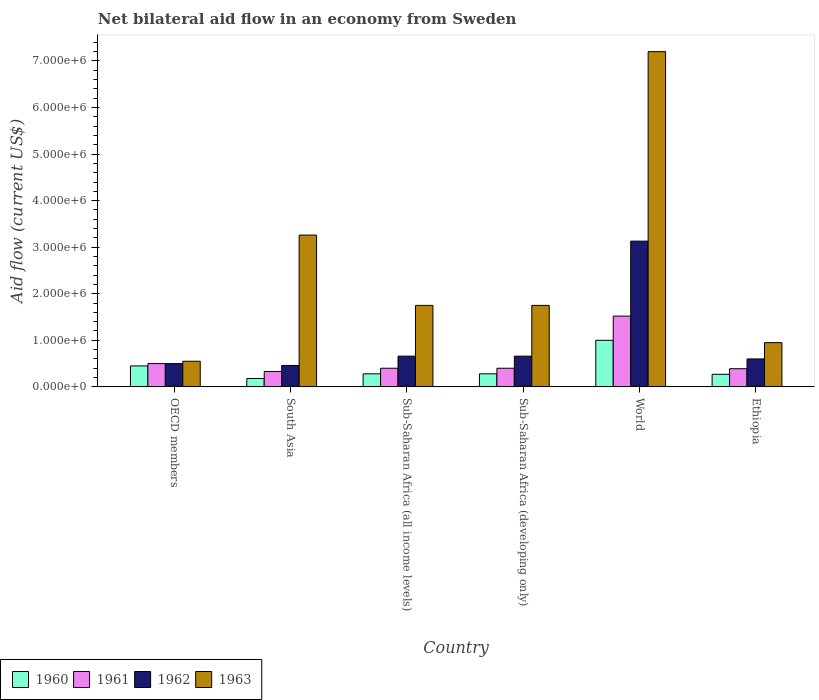How many different coloured bars are there?
Your answer should be very brief. 4. How many groups of bars are there?
Offer a terse response. 6. Are the number of bars per tick equal to the number of legend labels?
Offer a terse response. Yes. Are the number of bars on each tick of the X-axis equal?
Your response must be concise. Yes. How many bars are there on the 6th tick from the left?
Keep it short and to the point. 4. What is the label of the 2nd group of bars from the left?
Offer a very short reply. South Asia. What is the net bilateral aid flow in 1963 in OECD members?
Give a very brief answer. 5.50e+05. Across all countries, what is the maximum net bilateral aid flow in 1962?
Offer a terse response. 3.13e+06. Across all countries, what is the minimum net bilateral aid flow in 1960?
Make the answer very short. 1.80e+05. In which country was the net bilateral aid flow in 1962 maximum?
Provide a succinct answer. World. What is the total net bilateral aid flow in 1963 in the graph?
Ensure brevity in your answer.  1.55e+07. What is the difference between the net bilateral aid flow in 1963 in Ethiopia and that in Sub-Saharan Africa (developing only)?
Provide a short and direct response. -8.00e+05. What is the difference between the net bilateral aid flow in 1961 in World and the net bilateral aid flow in 1962 in Sub-Saharan Africa (all income levels)?
Make the answer very short. 8.60e+05. What is the average net bilateral aid flow in 1962 per country?
Your response must be concise. 1.00e+06. What is the difference between the net bilateral aid flow of/in 1963 and net bilateral aid flow of/in 1960 in Sub-Saharan Africa (developing only)?
Keep it short and to the point. 1.47e+06. What is the ratio of the net bilateral aid flow in 1961 in Ethiopia to that in Sub-Saharan Africa (developing only)?
Offer a terse response. 0.97. Is the net bilateral aid flow in 1960 in Sub-Saharan Africa (developing only) less than that in World?
Make the answer very short. Yes. Is the difference between the net bilateral aid flow in 1963 in OECD members and South Asia greater than the difference between the net bilateral aid flow in 1960 in OECD members and South Asia?
Your answer should be very brief. No. What is the difference between the highest and the second highest net bilateral aid flow in 1962?
Provide a short and direct response. 2.47e+06. What is the difference between the highest and the lowest net bilateral aid flow in 1961?
Offer a terse response. 1.19e+06. Is the sum of the net bilateral aid flow in 1962 in Sub-Saharan Africa (all income levels) and World greater than the maximum net bilateral aid flow in 1961 across all countries?
Give a very brief answer. Yes. Is it the case that in every country, the sum of the net bilateral aid flow in 1963 and net bilateral aid flow in 1960 is greater than the sum of net bilateral aid flow in 1961 and net bilateral aid flow in 1962?
Provide a succinct answer. Yes. Is it the case that in every country, the sum of the net bilateral aid flow in 1960 and net bilateral aid flow in 1962 is greater than the net bilateral aid flow in 1961?
Provide a succinct answer. Yes. How many bars are there?
Give a very brief answer. 24. Are all the bars in the graph horizontal?
Offer a terse response. No. Are the values on the major ticks of Y-axis written in scientific E-notation?
Your response must be concise. Yes. Does the graph contain grids?
Provide a succinct answer. No. Where does the legend appear in the graph?
Keep it short and to the point. Bottom left. How are the legend labels stacked?
Make the answer very short. Horizontal. What is the title of the graph?
Provide a short and direct response. Net bilateral aid flow in an economy from Sweden. What is the Aid flow (current US$) of 1961 in OECD members?
Your answer should be compact. 5.00e+05. What is the Aid flow (current US$) in 1962 in OECD members?
Make the answer very short. 5.00e+05. What is the Aid flow (current US$) in 1960 in South Asia?
Provide a short and direct response. 1.80e+05. What is the Aid flow (current US$) in 1963 in South Asia?
Offer a terse response. 3.26e+06. What is the Aid flow (current US$) in 1961 in Sub-Saharan Africa (all income levels)?
Your answer should be very brief. 4.00e+05. What is the Aid flow (current US$) of 1962 in Sub-Saharan Africa (all income levels)?
Ensure brevity in your answer.  6.60e+05. What is the Aid flow (current US$) of 1963 in Sub-Saharan Africa (all income levels)?
Provide a succinct answer. 1.75e+06. What is the Aid flow (current US$) in 1960 in Sub-Saharan Africa (developing only)?
Keep it short and to the point. 2.80e+05. What is the Aid flow (current US$) in 1962 in Sub-Saharan Africa (developing only)?
Keep it short and to the point. 6.60e+05. What is the Aid flow (current US$) in 1963 in Sub-Saharan Africa (developing only)?
Make the answer very short. 1.75e+06. What is the Aid flow (current US$) of 1960 in World?
Ensure brevity in your answer.  1.00e+06. What is the Aid flow (current US$) of 1961 in World?
Provide a succinct answer. 1.52e+06. What is the Aid flow (current US$) in 1962 in World?
Provide a succinct answer. 3.13e+06. What is the Aid flow (current US$) in 1963 in World?
Offer a terse response. 7.20e+06. What is the Aid flow (current US$) in 1961 in Ethiopia?
Give a very brief answer. 3.90e+05. What is the Aid flow (current US$) in 1962 in Ethiopia?
Give a very brief answer. 6.00e+05. What is the Aid flow (current US$) of 1963 in Ethiopia?
Make the answer very short. 9.50e+05. Across all countries, what is the maximum Aid flow (current US$) in 1961?
Give a very brief answer. 1.52e+06. Across all countries, what is the maximum Aid flow (current US$) of 1962?
Provide a succinct answer. 3.13e+06. Across all countries, what is the maximum Aid flow (current US$) of 1963?
Offer a very short reply. 7.20e+06. Across all countries, what is the minimum Aid flow (current US$) in 1961?
Your answer should be compact. 3.30e+05. Across all countries, what is the minimum Aid flow (current US$) in 1963?
Offer a very short reply. 5.50e+05. What is the total Aid flow (current US$) in 1960 in the graph?
Your answer should be very brief. 2.46e+06. What is the total Aid flow (current US$) in 1961 in the graph?
Provide a succinct answer. 3.54e+06. What is the total Aid flow (current US$) of 1962 in the graph?
Ensure brevity in your answer.  6.01e+06. What is the total Aid flow (current US$) in 1963 in the graph?
Your response must be concise. 1.55e+07. What is the difference between the Aid flow (current US$) of 1960 in OECD members and that in South Asia?
Offer a terse response. 2.70e+05. What is the difference between the Aid flow (current US$) of 1961 in OECD members and that in South Asia?
Provide a short and direct response. 1.70e+05. What is the difference between the Aid flow (current US$) of 1963 in OECD members and that in South Asia?
Make the answer very short. -2.71e+06. What is the difference between the Aid flow (current US$) of 1960 in OECD members and that in Sub-Saharan Africa (all income levels)?
Provide a succinct answer. 1.70e+05. What is the difference between the Aid flow (current US$) in 1963 in OECD members and that in Sub-Saharan Africa (all income levels)?
Make the answer very short. -1.20e+06. What is the difference between the Aid flow (current US$) of 1963 in OECD members and that in Sub-Saharan Africa (developing only)?
Keep it short and to the point. -1.20e+06. What is the difference between the Aid flow (current US$) of 1960 in OECD members and that in World?
Provide a short and direct response. -5.50e+05. What is the difference between the Aid flow (current US$) of 1961 in OECD members and that in World?
Your answer should be very brief. -1.02e+06. What is the difference between the Aid flow (current US$) of 1962 in OECD members and that in World?
Offer a very short reply. -2.63e+06. What is the difference between the Aid flow (current US$) of 1963 in OECD members and that in World?
Offer a very short reply. -6.65e+06. What is the difference between the Aid flow (current US$) in 1960 in OECD members and that in Ethiopia?
Your answer should be very brief. 1.80e+05. What is the difference between the Aid flow (current US$) of 1963 in OECD members and that in Ethiopia?
Offer a very short reply. -4.00e+05. What is the difference between the Aid flow (current US$) in 1963 in South Asia and that in Sub-Saharan Africa (all income levels)?
Offer a terse response. 1.51e+06. What is the difference between the Aid flow (current US$) of 1960 in South Asia and that in Sub-Saharan Africa (developing only)?
Make the answer very short. -1.00e+05. What is the difference between the Aid flow (current US$) in 1961 in South Asia and that in Sub-Saharan Africa (developing only)?
Offer a terse response. -7.00e+04. What is the difference between the Aid flow (current US$) in 1962 in South Asia and that in Sub-Saharan Africa (developing only)?
Make the answer very short. -2.00e+05. What is the difference between the Aid flow (current US$) of 1963 in South Asia and that in Sub-Saharan Africa (developing only)?
Your answer should be compact. 1.51e+06. What is the difference between the Aid flow (current US$) of 1960 in South Asia and that in World?
Provide a short and direct response. -8.20e+05. What is the difference between the Aid flow (current US$) of 1961 in South Asia and that in World?
Make the answer very short. -1.19e+06. What is the difference between the Aid flow (current US$) of 1962 in South Asia and that in World?
Provide a succinct answer. -2.67e+06. What is the difference between the Aid flow (current US$) in 1963 in South Asia and that in World?
Keep it short and to the point. -3.94e+06. What is the difference between the Aid flow (current US$) of 1960 in South Asia and that in Ethiopia?
Your answer should be very brief. -9.00e+04. What is the difference between the Aid flow (current US$) of 1963 in South Asia and that in Ethiopia?
Provide a succinct answer. 2.31e+06. What is the difference between the Aid flow (current US$) in 1960 in Sub-Saharan Africa (all income levels) and that in Sub-Saharan Africa (developing only)?
Offer a terse response. 0. What is the difference between the Aid flow (current US$) of 1962 in Sub-Saharan Africa (all income levels) and that in Sub-Saharan Africa (developing only)?
Offer a terse response. 0. What is the difference between the Aid flow (current US$) in 1963 in Sub-Saharan Africa (all income levels) and that in Sub-Saharan Africa (developing only)?
Give a very brief answer. 0. What is the difference between the Aid flow (current US$) in 1960 in Sub-Saharan Africa (all income levels) and that in World?
Keep it short and to the point. -7.20e+05. What is the difference between the Aid flow (current US$) in 1961 in Sub-Saharan Africa (all income levels) and that in World?
Offer a terse response. -1.12e+06. What is the difference between the Aid flow (current US$) in 1962 in Sub-Saharan Africa (all income levels) and that in World?
Your answer should be very brief. -2.47e+06. What is the difference between the Aid flow (current US$) in 1963 in Sub-Saharan Africa (all income levels) and that in World?
Provide a succinct answer. -5.45e+06. What is the difference between the Aid flow (current US$) of 1960 in Sub-Saharan Africa (all income levels) and that in Ethiopia?
Offer a terse response. 10000. What is the difference between the Aid flow (current US$) in 1963 in Sub-Saharan Africa (all income levels) and that in Ethiopia?
Your answer should be very brief. 8.00e+05. What is the difference between the Aid flow (current US$) of 1960 in Sub-Saharan Africa (developing only) and that in World?
Give a very brief answer. -7.20e+05. What is the difference between the Aid flow (current US$) in 1961 in Sub-Saharan Africa (developing only) and that in World?
Give a very brief answer. -1.12e+06. What is the difference between the Aid flow (current US$) in 1962 in Sub-Saharan Africa (developing only) and that in World?
Your answer should be very brief. -2.47e+06. What is the difference between the Aid flow (current US$) in 1963 in Sub-Saharan Africa (developing only) and that in World?
Give a very brief answer. -5.45e+06. What is the difference between the Aid flow (current US$) in 1963 in Sub-Saharan Africa (developing only) and that in Ethiopia?
Make the answer very short. 8.00e+05. What is the difference between the Aid flow (current US$) in 1960 in World and that in Ethiopia?
Your answer should be very brief. 7.30e+05. What is the difference between the Aid flow (current US$) in 1961 in World and that in Ethiopia?
Give a very brief answer. 1.13e+06. What is the difference between the Aid flow (current US$) of 1962 in World and that in Ethiopia?
Your answer should be very brief. 2.53e+06. What is the difference between the Aid flow (current US$) in 1963 in World and that in Ethiopia?
Offer a very short reply. 6.25e+06. What is the difference between the Aid flow (current US$) of 1960 in OECD members and the Aid flow (current US$) of 1962 in South Asia?
Offer a terse response. -10000. What is the difference between the Aid flow (current US$) in 1960 in OECD members and the Aid flow (current US$) in 1963 in South Asia?
Offer a terse response. -2.81e+06. What is the difference between the Aid flow (current US$) in 1961 in OECD members and the Aid flow (current US$) in 1962 in South Asia?
Provide a succinct answer. 4.00e+04. What is the difference between the Aid flow (current US$) in 1961 in OECD members and the Aid flow (current US$) in 1963 in South Asia?
Offer a terse response. -2.76e+06. What is the difference between the Aid flow (current US$) in 1962 in OECD members and the Aid flow (current US$) in 1963 in South Asia?
Your answer should be very brief. -2.76e+06. What is the difference between the Aid flow (current US$) in 1960 in OECD members and the Aid flow (current US$) in 1962 in Sub-Saharan Africa (all income levels)?
Provide a succinct answer. -2.10e+05. What is the difference between the Aid flow (current US$) of 1960 in OECD members and the Aid flow (current US$) of 1963 in Sub-Saharan Africa (all income levels)?
Provide a short and direct response. -1.30e+06. What is the difference between the Aid flow (current US$) in 1961 in OECD members and the Aid flow (current US$) in 1963 in Sub-Saharan Africa (all income levels)?
Make the answer very short. -1.25e+06. What is the difference between the Aid flow (current US$) in 1962 in OECD members and the Aid flow (current US$) in 1963 in Sub-Saharan Africa (all income levels)?
Give a very brief answer. -1.25e+06. What is the difference between the Aid flow (current US$) of 1960 in OECD members and the Aid flow (current US$) of 1961 in Sub-Saharan Africa (developing only)?
Provide a succinct answer. 5.00e+04. What is the difference between the Aid flow (current US$) of 1960 in OECD members and the Aid flow (current US$) of 1963 in Sub-Saharan Africa (developing only)?
Give a very brief answer. -1.30e+06. What is the difference between the Aid flow (current US$) in 1961 in OECD members and the Aid flow (current US$) in 1963 in Sub-Saharan Africa (developing only)?
Your answer should be compact. -1.25e+06. What is the difference between the Aid flow (current US$) of 1962 in OECD members and the Aid flow (current US$) of 1963 in Sub-Saharan Africa (developing only)?
Offer a very short reply. -1.25e+06. What is the difference between the Aid flow (current US$) in 1960 in OECD members and the Aid flow (current US$) in 1961 in World?
Provide a short and direct response. -1.07e+06. What is the difference between the Aid flow (current US$) of 1960 in OECD members and the Aid flow (current US$) of 1962 in World?
Keep it short and to the point. -2.68e+06. What is the difference between the Aid flow (current US$) of 1960 in OECD members and the Aid flow (current US$) of 1963 in World?
Provide a succinct answer. -6.75e+06. What is the difference between the Aid flow (current US$) in 1961 in OECD members and the Aid flow (current US$) in 1962 in World?
Make the answer very short. -2.63e+06. What is the difference between the Aid flow (current US$) of 1961 in OECD members and the Aid flow (current US$) of 1963 in World?
Give a very brief answer. -6.70e+06. What is the difference between the Aid flow (current US$) in 1962 in OECD members and the Aid flow (current US$) in 1963 in World?
Give a very brief answer. -6.70e+06. What is the difference between the Aid flow (current US$) of 1960 in OECD members and the Aid flow (current US$) of 1961 in Ethiopia?
Your answer should be compact. 6.00e+04. What is the difference between the Aid flow (current US$) in 1960 in OECD members and the Aid flow (current US$) in 1963 in Ethiopia?
Your answer should be compact. -5.00e+05. What is the difference between the Aid flow (current US$) of 1961 in OECD members and the Aid flow (current US$) of 1963 in Ethiopia?
Ensure brevity in your answer.  -4.50e+05. What is the difference between the Aid flow (current US$) of 1962 in OECD members and the Aid flow (current US$) of 1963 in Ethiopia?
Keep it short and to the point. -4.50e+05. What is the difference between the Aid flow (current US$) in 1960 in South Asia and the Aid flow (current US$) in 1961 in Sub-Saharan Africa (all income levels)?
Your answer should be very brief. -2.20e+05. What is the difference between the Aid flow (current US$) in 1960 in South Asia and the Aid flow (current US$) in 1962 in Sub-Saharan Africa (all income levels)?
Your response must be concise. -4.80e+05. What is the difference between the Aid flow (current US$) of 1960 in South Asia and the Aid flow (current US$) of 1963 in Sub-Saharan Africa (all income levels)?
Give a very brief answer. -1.57e+06. What is the difference between the Aid flow (current US$) in 1961 in South Asia and the Aid flow (current US$) in 1962 in Sub-Saharan Africa (all income levels)?
Your answer should be compact. -3.30e+05. What is the difference between the Aid flow (current US$) of 1961 in South Asia and the Aid flow (current US$) of 1963 in Sub-Saharan Africa (all income levels)?
Provide a short and direct response. -1.42e+06. What is the difference between the Aid flow (current US$) in 1962 in South Asia and the Aid flow (current US$) in 1963 in Sub-Saharan Africa (all income levels)?
Provide a short and direct response. -1.29e+06. What is the difference between the Aid flow (current US$) of 1960 in South Asia and the Aid flow (current US$) of 1962 in Sub-Saharan Africa (developing only)?
Your response must be concise. -4.80e+05. What is the difference between the Aid flow (current US$) of 1960 in South Asia and the Aid flow (current US$) of 1963 in Sub-Saharan Africa (developing only)?
Provide a succinct answer. -1.57e+06. What is the difference between the Aid flow (current US$) in 1961 in South Asia and the Aid flow (current US$) in 1962 in Sub-Saharan Africa (developing only)?
Give a very brief answer. -3.30e+05. What is the difference between the Aid flow (current US$) of 1961 in South Asia and the Aid flow (current US$) of 1963 in Sub-Saharan Africa (developing only)?
Offer a very short reply. -1.42e+06. What is the difference between the Aid flow (current US$) in 1962 in South Asia and the Aid flow (current US$) in 1963 in Sub-Saharan Africa (developing only)?
Your answer should be compact. -1.29e+06. What is the difference between the Aid flow (current US$) in 1960 in South Asia and the Aid flow (current US$) in 1961 in World?
Your answer should be compact. -1.34e+06. What is the difference between the Aid flow (current US$) in 1960 in South Asia and the Aid flow (current US$) in 1962 in World?
Make the answer very short. -2.95e+06. What is the difference between the Aid flow (current US$) in 1960 in South Asia and the Aid flow (current US$) in 1963 in World?
Your answer should be compact. -7.02e+06. What is the difference between the Aid flow (current US$) of 1961 in South Asia and the Aid flow (current US$) of 1962 in World?
Give a very brief answer. -2.80e+06. What is the difference between the Aid flow (current US$) in 1961 in South Asia and the Aid flow (current US$) in 1963 in World?
Ensure brevity in your answer.  -6.87e+06. What is the difference between the Aid flow (current US$) in 1962 in South Asia and the Aid flow (current US$) in 1963 in World?
Your answer should be very brief. -6.74e+06. What is the difference between the Aid flow (current US$) of 1960 in South Asia and the Aid flow (current US$) of 1961 in Ethiopia?
Ensure brevity in your answer.  -2.10e+05. What is the difference between the Aid flow (current US$) in 1960 in South Asia and the Aid flow (current US$) in 1962 in Ethiopia?
Offer a terse response. -4.20e+05. What is the difference between the Aid flow (current US$) in 1960 in South Asia and the Aid flow (current US$) in 1963 in Ethiopia?
Provide a short and direct response. -7.70e+05. What is the difference between the Aid flow (current US$) in 1961 in South Asia and the Aid flow (current US$) in 1963 in Ethiopia?
Your answer should be very brief. -6.20e+05. What is the difference between the Aid flow (current US$) in 1962 in South Asia and the Aid flow (current US$) in 1963 in Ethiopia?
Offer a terse response. -4.90e+05. What is the difference between the Aid flow (current US$) of 1960 in Sub-Saharan Africa (all income levels) and the Aid flow (current US$) of 1962 in Sub-Saharan Africa (developing only)?
Provide a succinct answer. -3.80e+05. What is the difference between the Aid flow (current US$) in 1960 in Sub-Saharan Africa (all income levels) and the Aid flow (current US$) in 1963 in Sub-Saharan Africa (developing only)?
Your response must be concise. -1.47e+06. What is the difference between the Aid flow (current US$) in 1961 in Sub-Saharan Africa (all income levels) and the Aid flow (current US$) in 1963 in Sub-Saharan Africa (developing only)?
Offer a very short reply. -1.35e+06. What is the difference between the Aid flow (current US$) of 1962 in Sub-Saharan Africa (all income levels) and the Aid flow (current US$) of 1963 in Sub-Saharan Africa (developing only)?
Offer a terse response. -1.09e+06. What is the difference between the Aid flow (current US$) of 1960 in Sub-Saharan Africa (all income levels) and the Aid flow (current US$) of 1961 in World?
Your response must be concise. -1.24e+06. What is the difference between the Aid flow (current US$) of 1960 in Sub-Saharan Africa (all income levels) and the Aid flow (current US$) of 1962 in World?
Make the answer very short. -2.85e+06. What is the difference between the Aid flow (current US$) in 1960 in Sub-Saharan Africa (all income levels) and the Aid flow (current US$) in 1963 in World?
Give a very brief answer. -6.92e+06. What is the difference between the Aid flow (current US$) of 1961 in Sub-Saharan Africa (all income levels) and the Aid flow (current US$) of 1962 in World?
Keep it short and to the point. -2.73e+06. What is the difference between the Aid flow (current US$) in 1961 in Sub-Saharan Africa (all income levels) and the Aid flow (current US$) in 1963 in World?
Keep it short and to the point. -6.80e+06. What is the difference between the Aid flow (current US$) in 1962 in Sub-Saharan Africa (all income levels) and the Aid flow (current US$) in 1963 in World?
Give a very brief answer. -6.54e+06. What is the difference between the Aid flow (current US$) of 1960 in Sub-Saharan Africa (all income levels) and the Aid flow (current US$) of 1962 in Ethiopia?
Give a very brief answer. -3.20e+05. What is the difference between the Aid flow (current US$) of 1960 in Sub-Saharan Africa (all income levels) and the Aid flow (current US$) of 1963 in Ethiopia?
Your answer should be compact. -6.70e+05. What is the difference between the Aid flow (current US$) of 1961 in Sub-Saharan Africa (all income levels) and the Aid flow (current US$) of 1962 in Ethiopia?
Your answer should be compact. -2.00e+05. What is the difference between the Aid flow (current US$) of 1961 in Sub-Saharan Africa (all income levels) and the Aid flow (current US$) of 1963 in Ethiopia?
Your answer should be compact. -5.50e+05. What is the difference between the Aid flow (current US$) of 1962 in Sub-Saharan Africa (all income levels) and the Aid flow (current US$) of 1963 in Ethiopia?
Make the answer very short. -2.90e+05. What is the difference between the Aid flow (current US$) in 1960 in Sub-Saharan Africa (developing only) and the Aid flow (current US$) in 1961 in World?
Your answer should be very brief. -1.24e+06. What is the difference between the Aid flow (current US$) of 1960 in Sub-Saharan Africa (developing only) and the Aid flow (current US$) of 1962 in World?
Ensure brevity in your answer.  -2.85e+06. What is the difference between the Aid flow (current US$) of 1960 in Sub-Saharan Africa (developing only) and the Aid flow (current US$) of 1963 in World?
Provide a succinct answer. -6.92e+06. What is the difference between the Aid flow (current US$) in 1961 in Sub-Saharan Africa (developing only) and the Aid flow (current US$) in 1962 in World?
Ensure brevity in your answer.  -2.73e+06. What is the difference between the Aid flow (current US$) of 1961 in Sub-Saharan Africa (developing only) and the Aid flow (current US$) of 1963 in World?
Provide a short and direct response. -6.80e+06. What is the difference between the Aid flow (current US$) of 1962 in Sub-Saharan Africa (developing only) and the Aid flow (current US$) of 1963 in World?
Your response must be concise. -6.54e+06. What is the difference between the Aid flow (current US$) of 1960 in Sub-Saharan Africa (developing only) and the Aid flow (current US$) of 1961 in Ethiopia?
Your response must be concise. -1.10e+05. What is the difference between the Aid flow (current US$) of 1960 in Sub-Saharan Africa (developing only) and the Aid flow (current US$) of 1962 in Ethiopia?
Ensure brevity in your answer.  -3.20e+05. What is the difference between the Aid flow (current US$) of 1960 in Sub-Saharan Africa (developing only) and the Aid flow (current US$) of 1963 in Ethiopia?
Provide a succinct answer. -6.70e+05. What is the difference between the Aid flow (current US$) of 1961 in Sub-Saharan Africa (developing only) and the Aid flow (current US$) of 1962 in Ethiopia?
Make the answer very short. -2.00e+05. What is the difference between the Aid flow (current US$) in 1961 in Sub-Saharan Africa (developing only) and the Aid flow (current US$) in 1963 in Ethiopia?
Your response must be concise. -5.50e+05. What is the difference between the Aid flow (current US$) in 1960 in World and the Aid flow (current US$) in 1962 in Ethiopia?
Give a very brief answer. 4.00e+05. What is the difference between the Aid flow (current US$) of 1960 in World and the Aid flow (current US$) of 1963 in Ethiopia?
Keep it short and to the point. 5.00e+04. What is the difference between the Aid flow (current US$) of 1961 in World and the Aid flow (current US$) of 1962 in Ethiopia?
Offer a terse response. 9.20e+05. What is the difference between the Aid flow (current US$) in 1961 in World and the Aid flow (current US$) in 1963 in Ethiopia?
Provide a short and direct response. 5.70e+05. What is the difference between the Aid flow (current US$) of 1962 in World and the Aid flow (current US$) of 1963 in Ethiopia?
Give a very brief answer. 2.18e+06. What is the average Aid flow (current US$) of 1960 per country?
Provide a succinct answer. 4.10e+05. What is the average Aid flow (current US$) in 1961 per country?
Offer a terse response. 5.90e+05. What is the average Aid flow (current US$) of 1962 per country?
Keep it short and to the point. 1.00e+06. What is the average Aid flow (current US$) of 1963 per country?
Your response must be concise. 2.58e+06. What is the difference between the Aid flow (current US$) of 1960 and Aid flow (current US$) of 1962 in OECD members?
Your answer should be very brief. -5.00e+04. What is the difference between the Aid flow (current US$) in 1960 and Aid flow (current US$) in 1963 in OECD members?
Offer a very short reply. -1.00e+05. What is the difference between the Aid flow (current US$) of 1961 and Aid flow (current US$) of 1962 in OECD members?
Make the answer very short. 0. What is the difference between the Aid flow (current US$) of 1961 and Aid flow (current US$) of 1963 in OECD members?
Ensure brevity in your answer.  -5.00e+04. What is the difference between the Aid flow (current US$) of 1960 and Aid flow (current US$) of 1961 in South Asia?
Keep it short and to the point. -1.50e+05. What is the difference between the Aid flow (current US$) of 1960 and Aid flow (current US$) of 1962 in South Asia?
Offer a terse response. -2.80e+05. What is the difference between the Aid flow (current US$) in 1960 and Aid flow (current US$) in 1963 in South Asia?
Your answer should be very brief. -3.08e+06. What is the difference between the Aid flow (current US$) in 1961 and Aid flow (current US$) in 1962 in South Asia?
Provide a succinct answer. -1.30e+05. What is the difference between the Aid flow (current US$) in 1961 and Aid flow (current US$) in 1963 in South Asia?
Make the answer very short. -2.93e+06. What is the difference between the Aid flow (current US$) in 1962 and Aid flow (current US$) in 1963 in South Asia?
Your answer should be very brief. -2.80e+06. What is the difference between the Aid flow (current US$) of 1960 and Aid flow (current US$) of 1962 in Sub-Saharan Africa (all income levels)?
Your answer should be compact. -3.80e+05. What is the difference between the Aid flow (current US$) of 1960 and Aid flow (current US$) of 1963 in Sub-Saharan Africa (all income levels)?
Your answer should be compact. -1.47e+06. What is the difference between the Aid flow (current US$) of 1961 and Aid flow (current US$) of 1962 in Sub-Saharan Africa (all income levels)?
Ensure brevity in your answer.  -2.60e+05. What is the difference between the Aid flow (current US$) of 1961 and Aid flow (current US$) of 1963 in Sub-Saharan Africa (all income levels)?
Your answer should be very brief. -1.35e+06. What is the difference between the Aid flow (current US$) in 1962 and Aid flow (current US$) in 1963 in Sub-Saharan Africa (all income levels)?
Give a very brief answer. -1.09e+06. What is the difference between the Aid flow (current US$) in 1960 and Aid flow (current US$) in 1961 in Sub-Saharan Africa (developing only)?
Your answer should be very brief. -1.20e+05. What is the difference between the Aid flow (current US$) in 1960 and Aid flow (current US$) in 1962 in Sub-Saharan Africa (developing only)?
Give a very brief answer. -3.80e+05. What is the difference between the Aid flow (current US$) of 1960 and Aid flow (current US$) of 1963 in Sub-Saharan Africa (developing only)?
Provide a succinct answer. -1.47e+06. What is the difference between the Aid flow (current US$) of 1961 and Aid flow (current US$) of 1963 in Sub-Saharan Africa (developing only)?
Provide a short and direct response. -1.35e+06. What is the difference between the Aid flow (current US$) in 1962 and Aid flow (current US$) in 1963 in Sub-Saharan Africa (developing only)?
Make the answer very short. -1.09e+06. What is the difference between the Aid flow (current US$) of 1960 and Aid flow (current US$) of 1961 in World?
Your response must be concise. -5.20e+05. What is the difference between the Aid flow (current US$) in 1960 and Aid flow (current US$) in 1962 in World?
Provide a short and direct response. -2.13e+06. What is the difference between the Aid flow (current US$) in 1960 and Aid flow (current US$) in 1963 in World?
Make the answer very short. -6.20e+06. What is the difference between the Aid flow (current US$) of 1961 and Aid flow (current US$) of 1962 in World?
Your response must be concise. -1.61e+06. What is the difference between the Aid flow (current US$) in 1961 and Aid flow (current US$) in 1963 in World?
Provide a succinct answer. -5.68e+06. What is the difference between the Aid flow (current US$) of 1962 and Aid flow (current US$) of 1963 in World?
Make the answer very short. -4.07e+06. What is the difference between the Aid flow (current US$) in 1960 and Aid flow (current US$) in 1962 in Ethiopia?
Your response must be concise. -3.30e+05. What is the difference between the Aid flow (current US$) of 1960 and Aid flow (current US$) of 1963 in Ethiopia?
Your answer should be very brief. -6.80e+05. What is the difference between the Aid flow (current US$) in 1961 and Aid flow (current US$) in 1963 in Ethiopia?
Your answer should be very brief. -5.60e+05. What is the difference between the Aid flow (current US$) of 1962 and Aid flow (current US$) of 1963 in Ethiopia?
Ensure brevity in your answer.  -3.50e+05. What is the ratio of the Aid flow (current US$) in 1960 in OECD members to that in South Asia?
Keep it short and to the point. 2.5. What is the ratio of the Aid flow (current US$) in 1961 in OECD members to that in South Asia?
Ensure brevity in your answer.  1.52. What is the ratio of the Aid flow (current US$) in 1962 in OECD members to that in South Asia?
Give a very brief answer. 1.09. What is the ratio of the Aid flow (current US$) in 1963 in OECD members to that in South Asia?
Your response must be concise. 0.17. What is the ratio of the Aid flow (current US$) in 1960 in OECD members to that in Sub-Saharan Africa (all income levels)?
Provide a short and direct response. 1.61. What is the ratio of the Aid flow (current US$) in 1962 in OECD members to that in Sub-Saharan Africa (all income levels)?
Make the answer very short. 0.76. What is the ratio of the Aid flow (current US$) in 1963 in OECD members to that in Sub-Saharan Africa (all income levels)?
Provide a short and direct response. 0.31. What is the ratio of the Aid flow (current US$) in 1960 in OECD members to that in Sub-Saharan Africa (developing only)?
Provide a short and direct response. 1.61. What is the ratio of the Aid flow (current US$) of 1962 in OECD members to that in Sub-Saharan Africa (developing only)?
Offer a very short reply. 0.76. What is the ratio of the Aid flow (current US$) of 1963 in OECD members to that in Sub-Saharan Africa (developing only)?
Your response must be concise. 0.31. What is the ratio of the Aid flow (current US$) of 1960 in OECD members to that in World?
Your answer should be very brief. 0.45. What is the ratio of the Aid flow (current US$) of 1961 in OECD members to that in World?
Provide a succinct answer. 0.33. What is the ratio of the Aid flow (current US$) in 1962 in OECD members to that in World?
Provide a succinct answer. 0.16. What is the ratio of the Aid flow (current US$) in 1963 in OECD members to that in World?
Provide a succinct answer. 0.08. What is the ratio of the Aid flow (current US$) in 1961 in OECD members to that in Ethiopia?
Your answer should be very brief. 1.28. What is the ratio of the Aid flow (current US$) of 1963 in OECD members to that in Ethiopia?
Give a very brief answer. 0.58. What is the ratio of the Aid flow (current US$) of 1960 in South Asia to that in Sub-Saharan Africa (all income levels)?
Your response must be concise. 0.64. What is the ratio of the Aid flow (current US$) in 1961 in South Asia to that in Sub-Saharan Africa (all income levels)?
Keep it short and to the point. 0.82. What is the ratio of the Aid flow (current US$) of 1962 in South Asia to that in Sub-Saharan Africa (all income levels)?
Your answer should be compact. 0.7. What is the ratio of the Aid flow (current US$) of 1963 in South Asia to that in Sub-Saharan Africa (all income levels)?
Offer a terse response. 1.86. What is the ratio of the Aid flow (current US$) in 1960 in South Asia to that in Sub-Saharan Africa (developing only)?
Provide a short and direct response. 0.64. What is the ratio of the Aid flow (current US$) of 1961 in South Asia to that in Sub-Saharan Africa (developing only)?
Provide a succinct answer. 0.82. What is the ratio of the Aid flow (current US$) in 1962 in South Asia to that in Sub-Saharan Africa (developing only)?
Your response must be concise. 0.7. What is the ratio of the Aid flow (current US$) of 1963 in South Asia to that in Sub-Saharan Africa (developing only)?
Give a very brief answer. 1.86. What is the ratio of the Aid flow (current US$) in 1960 in South Asia to that in World?
Give a very brief answer. 0.18. What is the ratio of the Aid flow (current US$) of 1961 in South Asia to that in World?
Your answer should be very brief. 0.22. What is the ratio of the Aid flow (current US$) of 1962 in South Asia to that in World?
Offer a terse response. 0.15. What is the ratio of the Aid flow (current US$) in 1963 in South Asia to that in World?
Provide a short and direct response. 0.45. What is the ratio of the Aid flow (current US$) of 1960 in South Asia to that in Ethiopia?
Your answer should be very brief. 0.67. What is the ratio of the Aid flow (current US$) of 1961 in South Asia to that in Ethiopia?
Your answer should be compact. 0.85. What is the ratio of the Aid flow (current US$) in 1962 in South Asia to that in Ethiopia?
Provide a short and direct response. 0.77. What is the ratio of the Aid flow (current US$) of 1963 in South Asia to that in Ethiopia?
Your response must be concise. 3.43. What is the ratio of the Aid flow (current US$) of 1961 in Sub-Saharan Africa (all income levels) to that in Sub-Saharan Africa (developing only)?
Provide a short and direct response. 1. What is the ratio of the Aid flow (current US$) of 1960 in Sub-Saharan Africa (all income levels) to that in World?
Your response must be concise. 0.28. What is the ratio of the Aid flow (current US$) of 1961 in Sub-Saharan Africa (all income levels) to that in World?
Your answer should be very brief. 0.26. What is the ratio of the Aid flow (current US$) in 1962 in Sub-Saharan Africa (all income levels) to that in World?
Keep it short and to the point. 0.21. What is the ratio of the Aid flow (current US$) of 1963 in Sub-Saharan Africa (all income levels) to that in World?
Provide a succinct answer. 0.24. What is the ratio of the Aid flow (current US$) of 1961 in Sub-Saharan Africa (all income levels) to that in Ethiopia?
Offer a terse response. 1.03. What is the ratio of the Aid flow (current US$) of 1962 in Sub-Saharan Africa (all income levels) to that in Ethiopia?
Make the answer very short. 1.1. What is the ratio of the Aid flow (current US$) of 1963 in Sub-Saharan Africa (all income levels) to that in Ethiopia?
Ensure brevity in your answer.  1.84. What is the ratio of the Aid flow (current US$) of 1960 in Sub-Saharan Africa (developing only) to that in World?
Give a very brief answer. 0.28. What is the ratio of the Aid flow (current US$) in 1961 in Sub-Saharan Africa (developing only) to that in World?
Offer a very short reply. 0.26. What is the ratio of the Aid flow (current US$) in 1962 in Sub-Saharan Africa (developing only) to that in World?
Your response must be concise. 0.21. What is the ratio of the Aid flow (current US$) of 1963 in Sub-Saharan Africa (developing only) to that in World?
Your response must be concise. 0.24. What is the ratio of the Aid flow (current US$) of 1960 in Sub-Saharan Africa (developing only) to that in Ethiopia?
Offer a very short reply. 1.04. What is the ratio of the Aid flow (current US$) in 1961 in Sub-Saharan Africa (developing only) to that in Ethiopia?
Your response must be concise. 1.03. What is the ratio of the Aid flow (current US$) of 1962 in Sub-Saharan Africa (developing only) to that in Ethiopia?
Give a very brief answer. 1.1. What is the ratio of the Aid flow (current US$) in 1963 in Sub-Saharan Africa (developing only) to that in Ethiopia?
Your answer should be compact. 1.84. What is the ratio of the Aid flow (current US$) of 1960 in World to that in Ethiopia?
Ensure brevity in your answer.  3.7. What is the ratio of the Aid flow (current US$) in 1961 in World to that in Ethiopia?
Offer a very short reply. 3.9. What is the ratio of the Aid flow (current US$) in 1962 in World to that in Ethiopia?
Provide a succinct answer. 5.22. What is the ratio of the Aid flow (current US$) of 1963 in World to that in Ethiopia?
Provide a short and direct response. 7.58. What is the difference between the highest and the second highest Aid flow (current US$) of 1960?
Give a very brief answer. 5.50e+05. What is the difference between the highest and the second highest Aid flow (current US$) of 1961?
Offer a very short reply. 1.02e+06. What is the difference between the highest and the second highest Aid flow (current US$) of 1962?
Offer a terse response. 2.47e+06. What is the difference between the highest and the second highest Aid flow (current US$) in 1963?
Provide a succinct answer. 3.94e+06. What is the difference between the highest and the lowest Aid flow (current US$) of 1960?
Give a very brief answer. 8.20e+05. What is the difference between the highest and the lowest Aid flow (current US$) of 1961?
Your answer should be very brief. 1.19e+06. What is the difference between the highest and the lowest Aid flow (current US$) in 1962?
Provide a succinct answer. 2.67e+06. What is the difference between the highest and the lowest Aid flow (current US$) of 1963?
Give a very brief answer. 6.65e+06. 